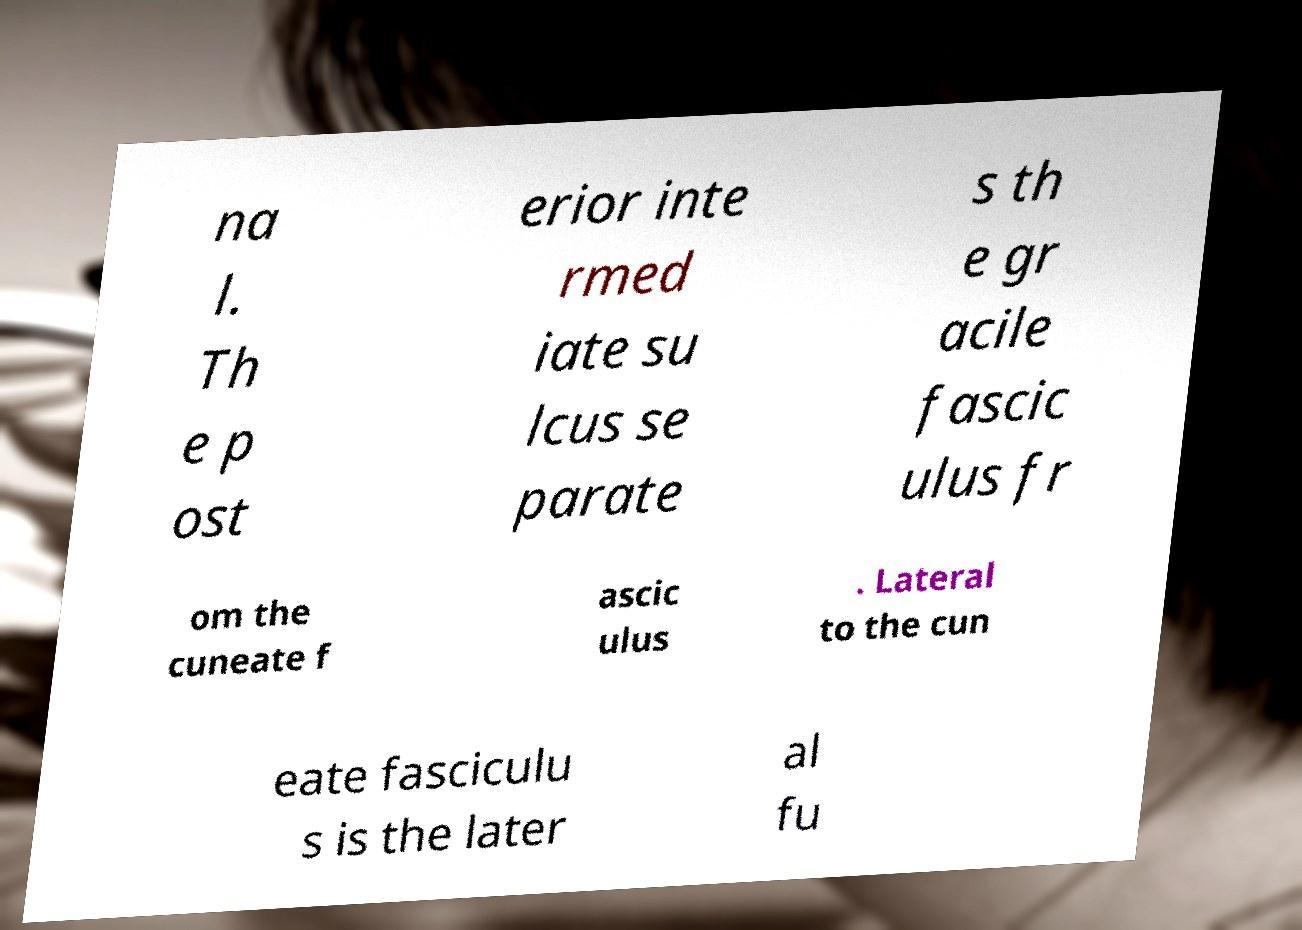I need the written content from this picture converted into text. Can you do that? na l. Th e p ost erior inte rmed iate su lcus se parate s th e gr acile fascic ulus fr om the cuneate f ascic ulus . Lateral to the cun eate fasciculu s is the later al fu 